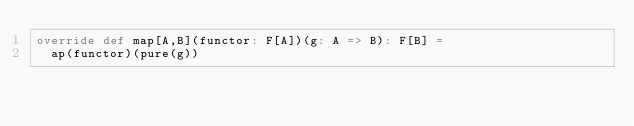<code> <loc_0><loc_0><loc_500><loc_500><_Scala_>override def map[A,B](functor: F[A])(g: A => B): F[B] =
  ap(functor)(pure(g))
</code> 